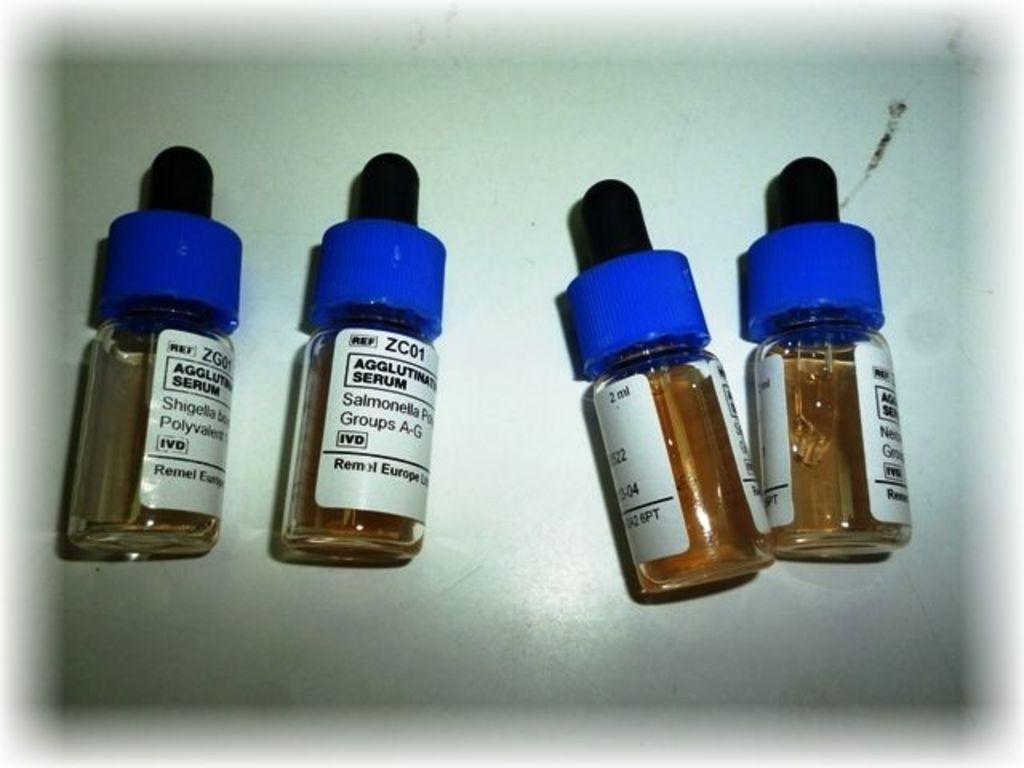<image>
Present a compact description of the photo's key features. Four vials of vaccinations are in a bin, including one for Shigella. 